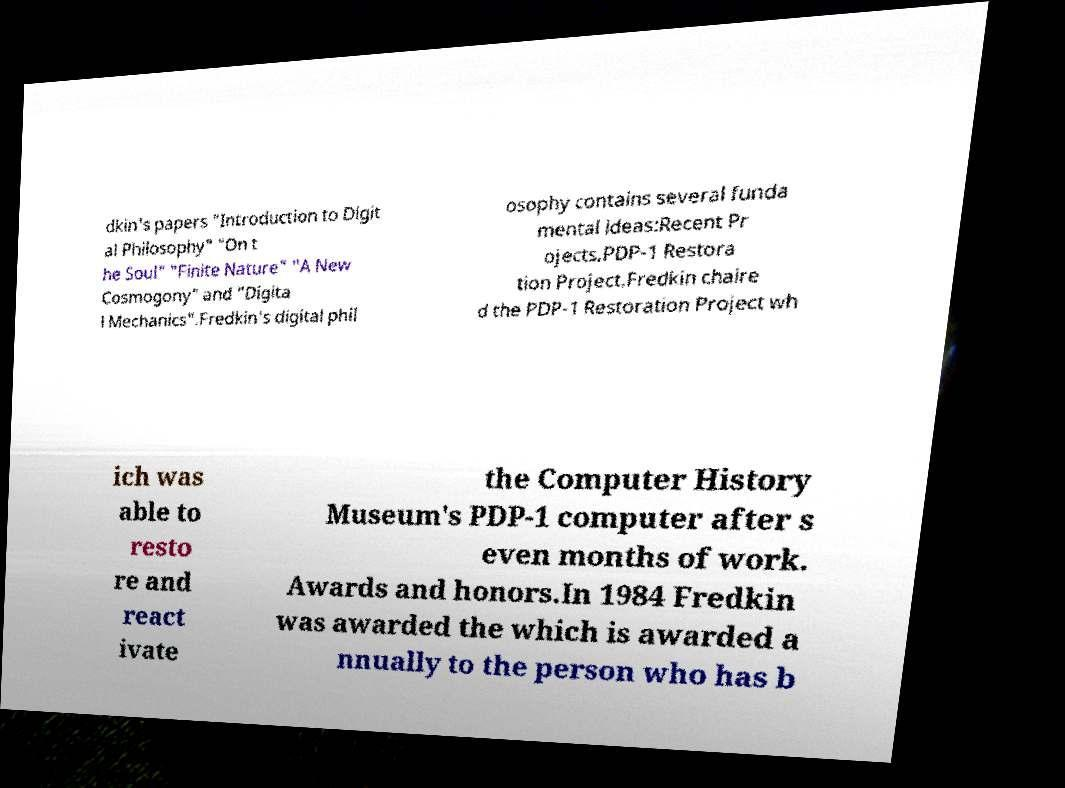Please read and relay the text visible in this image. What does it say? dkin's papers "Introduction to Digit al Philosophy" "On t he Soul" "Finite Nature" "A New Cosmogony" and "Digita l Mechanics".Fredkin's digital phil osophy contains several funda mental ideas:Recent Pr ojects.PDP-1 Restora tion Project.Fredkin chaire d the PDP-1 Restoration Project wh ich was able to resto re and react ivate the Computer History Museum's PDP-1 computer after s even months of work. Awards and honors.In 1984 Fredkin was awarded the which is awarded a nnually to the person who has b 